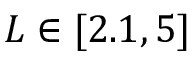Convert formula to latex. <formula><loc_0><loc_0><loc_500><loc_500>L \in [ 2 . 1 , 5 ]</formula> 